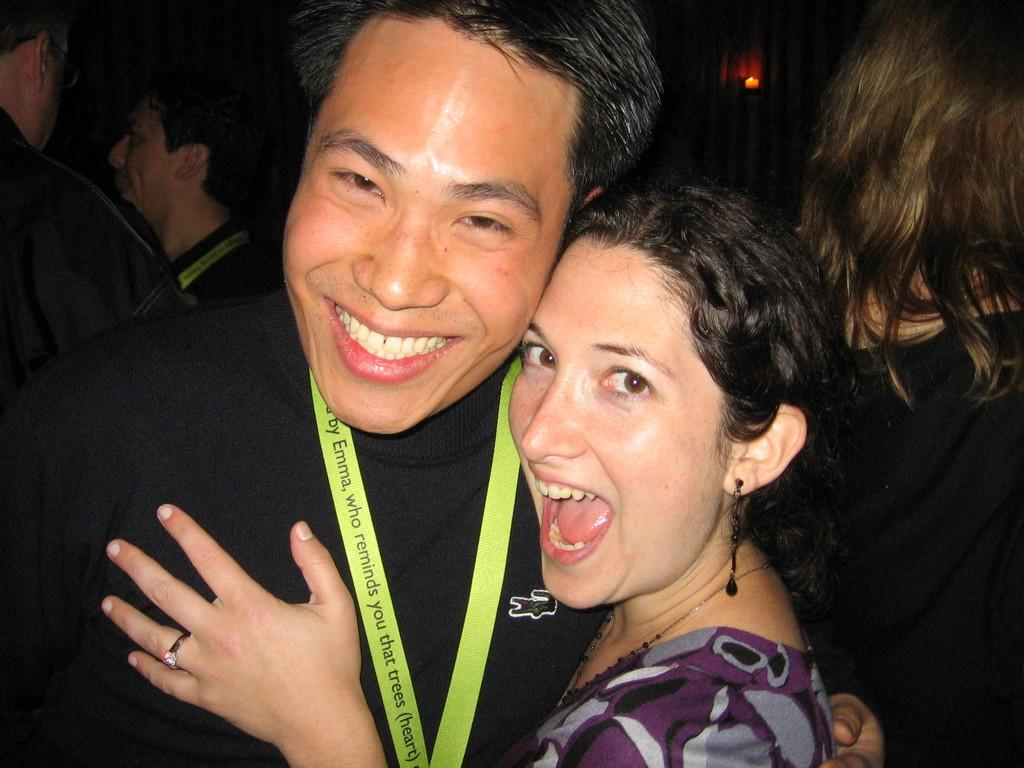What is the gender of the person in the image who is wearing a black dress? The person wearing a black dress is a man. What is the emotional expression of the man in the image? The man is smiling. What is the color of the woman's dress in the image? The woman is wearing a purple-grey dress. What is the emotional expression of the woman in the image? The woman is smiling. Can you describe the people behind the man and woman in the image? There are people behind the man and woman, but their specific features cannot be determined from the provided facts. What type of clam is being used as a prop in the image? There is no clam present in the image. What is the cause of the war depicted in the image? There is no war depicted in the image. 